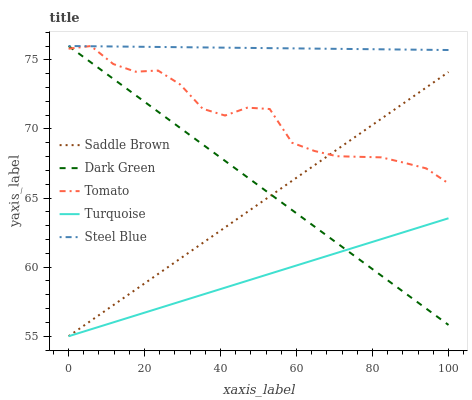Does Turquoise have the minimum area under the curve?
Answer yes or no. Yes. Does Steel Blue have the maximum area under the curve?
Answer yes or no. Yes. Does Saddle Brown have the minimum area under the curve?
Answer yes or no. No. Does Saddle Brown have the maximum area under the curve?
Answer yes or no. No. Is Dark Green the smoothest?
Answer yes or no. Yes. Is Tomato the roughest?
Answer yes or no. Yes. Is Turquoise the smoothest?
Answer yes or no. No. Is Turquoise the roughest?
Answer yes or no. No. Does Turquoise have the lowest value?
Answer yes or no. Yes. Does Steel Blue have the lowest value?
Answer yes or no. No. Does Dark Green have the highest value?
Answer yes or no. Yes. Does Saddle Brown have the highest value?
Answer yes or no. No. Is Turquoise less than Tomato?
Answer yes or no. Yes. Is Steel Blue greater than Saddle Brown?
Answer yes or no. Yes. Does Dark Green intersect Turquoise?
Answer yes or no. Yes. Is Dark Green less than Turquoise?
Answer yes or no. No. Is Dark Green greater than Turquoise?
Answer yes or no. No. Does Turquoise intersect Tomato?
Answer yes or no. No. 